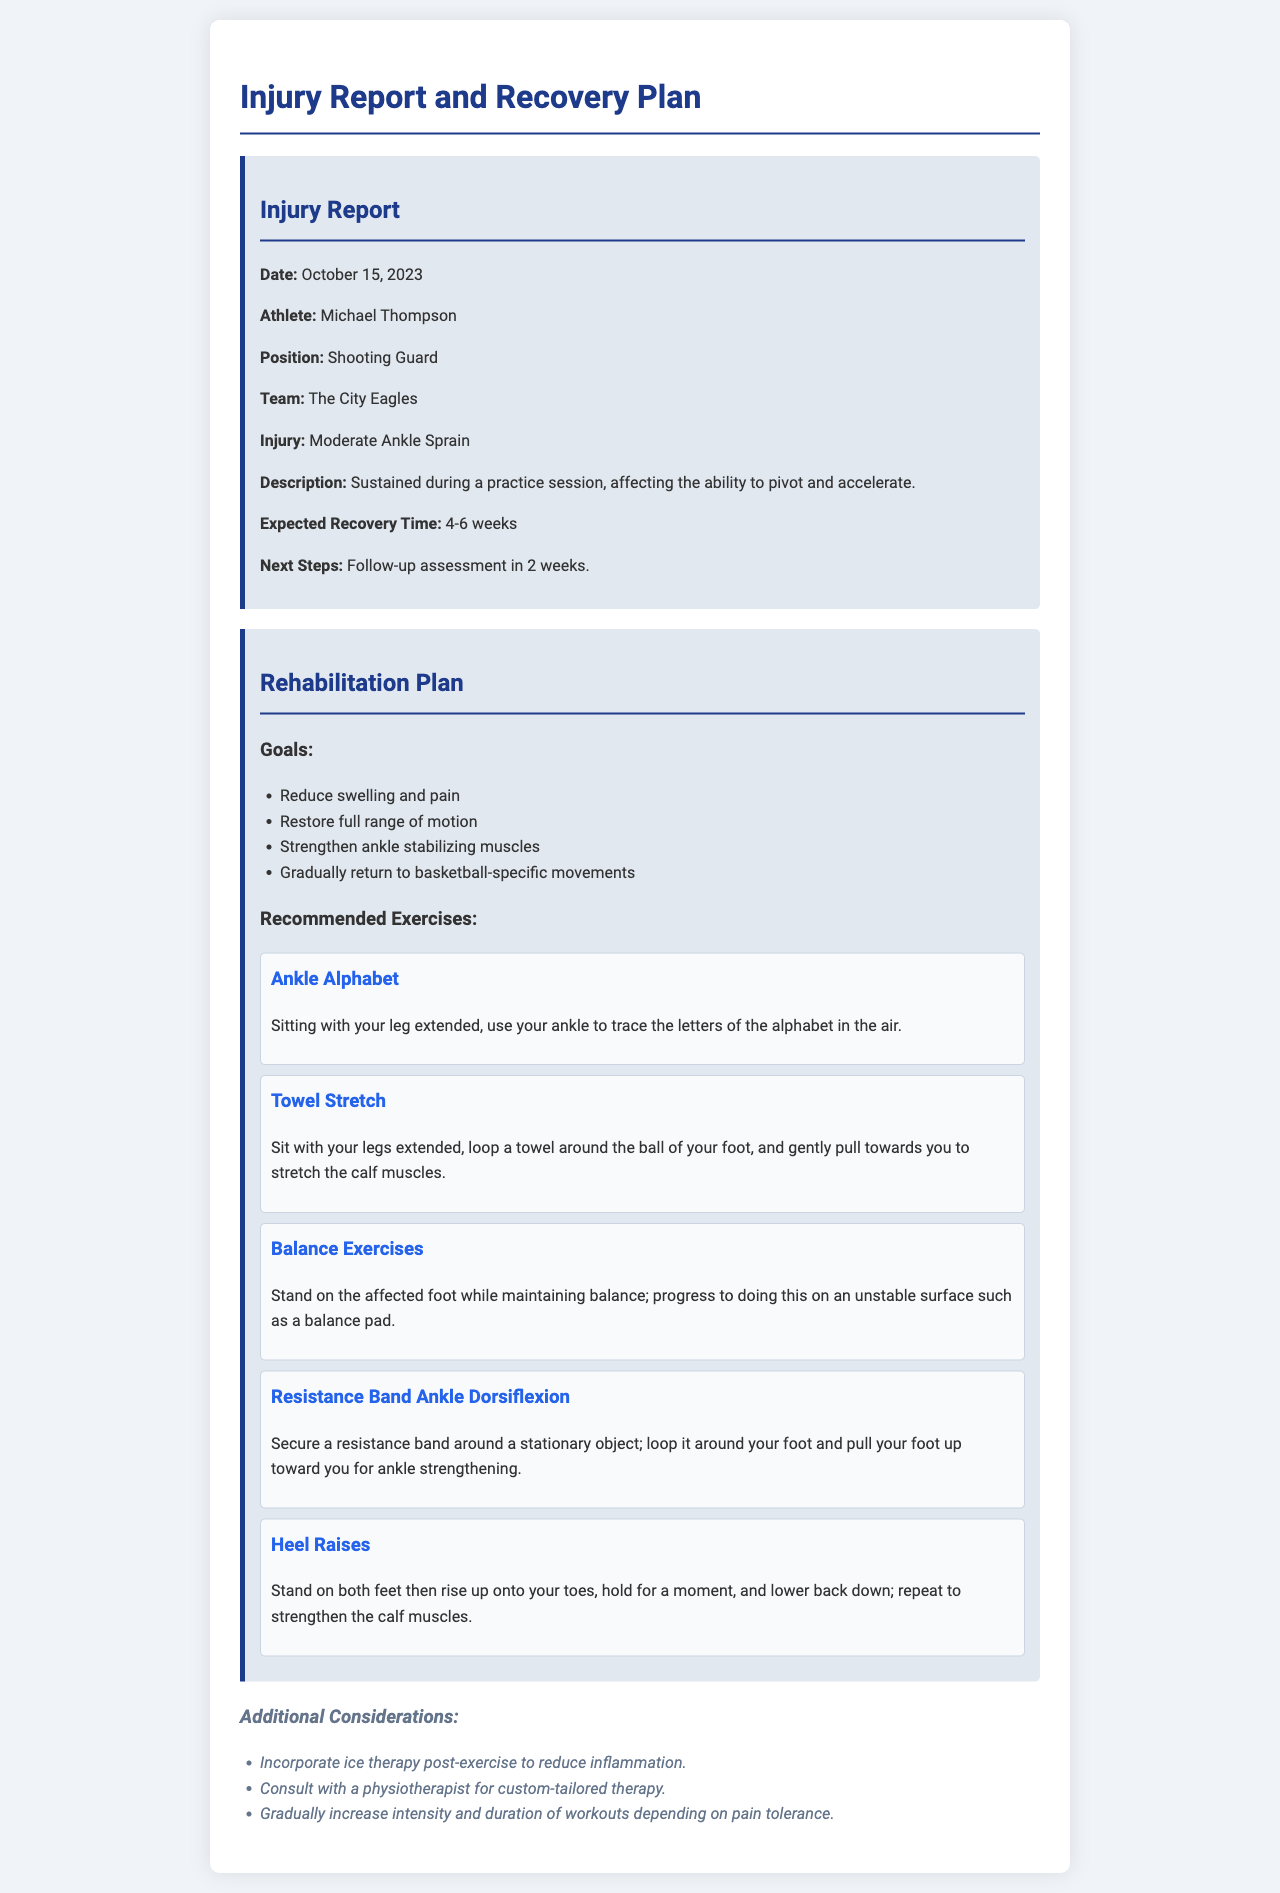What is the date of the injury? The date of the injury is stated in the document under Injury Report.
Answer: October 15, 2023 Who is the athlete mentioned in the report? The athlete's name is specified in the document under Injury Report.
Answer: Michael Thompson What is the expected recovery time for the injury? The expected recovery time is noted in the document under Injury Report.
Answer: 4-6 weeks What exercise involves tracing letters with the ankle? The exercise focused on tracing letters is listed in the Rehabilitation Plan section.
Answer: Ankle Alphabet What goal of the rehabilitation plan involves reducing swelling? Goals of the rehabilitation plan are outlined; one aims to address swelling.
Answer: Reduce swelling and pain What type of injury is reported? The type of injury is categorized in the Injury Report section.
Answer: Moderate Ankle Sprain What should be incorporated post-exercise to reduce inflammation? The document suggests measures post-exercise to aid in recovery.
Answer: Ice therapy What exercise uses a towel for stretching? The exercise that involves a towel is detailed in the Rehabilitation Plan.
Answer: Towel Stretch Which exercise uses a resistance band? The specific exercise using a resistance band is mentioned in the Rehabilitation Plan.
Answer: Resistance Band Ankle Dorsiflexion 